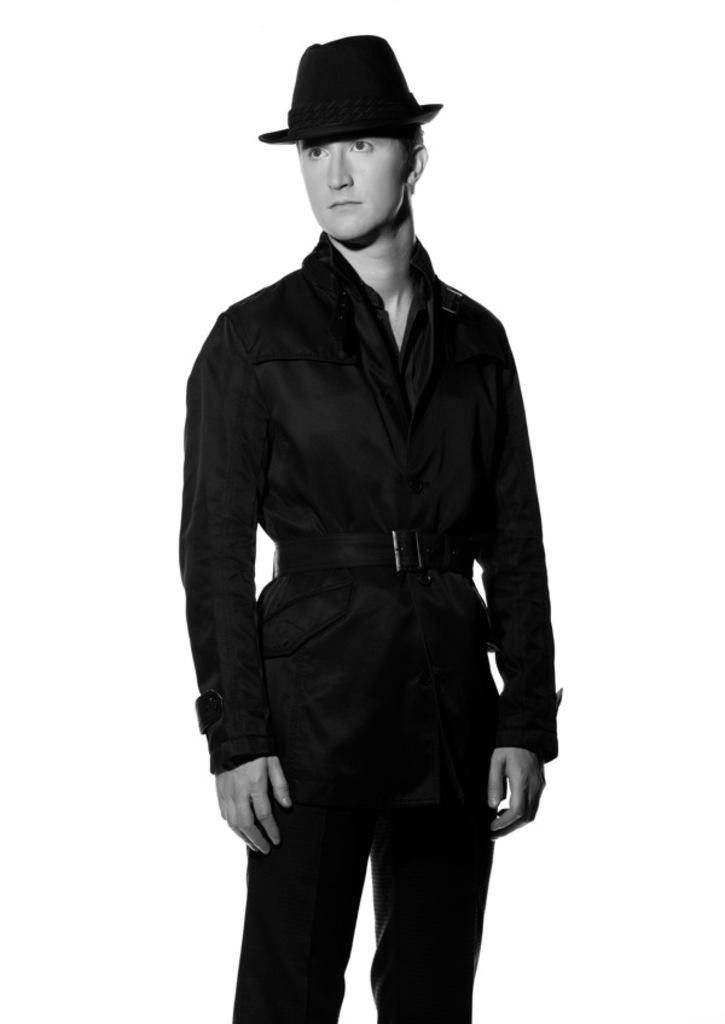What is the main subject of the image? The main subject of the image is a man. Can you describe the man's position in the image? The man is standing in the center of the image. What type of clothing accessory is the man wearing? The man is wearing a hat. How many snakes are wrapped around the man's legs in the image? There are no snakes present in the image. What type of rod is the man holding in the image? There is no rod present in the image. What kind of flower is the man holding in the image? There is no flower present in the image. 